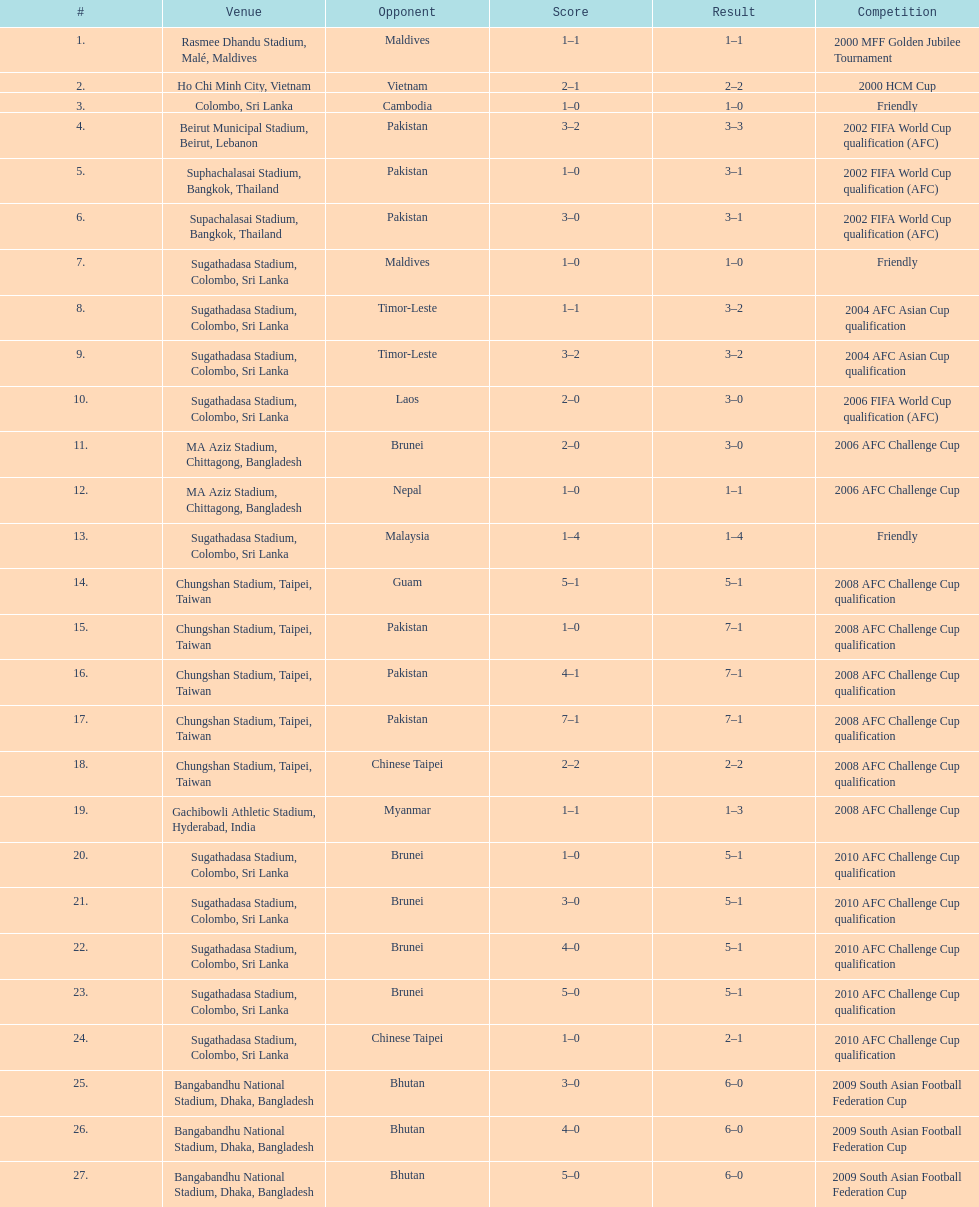What is the quantity of games played against vietnam? 1. 